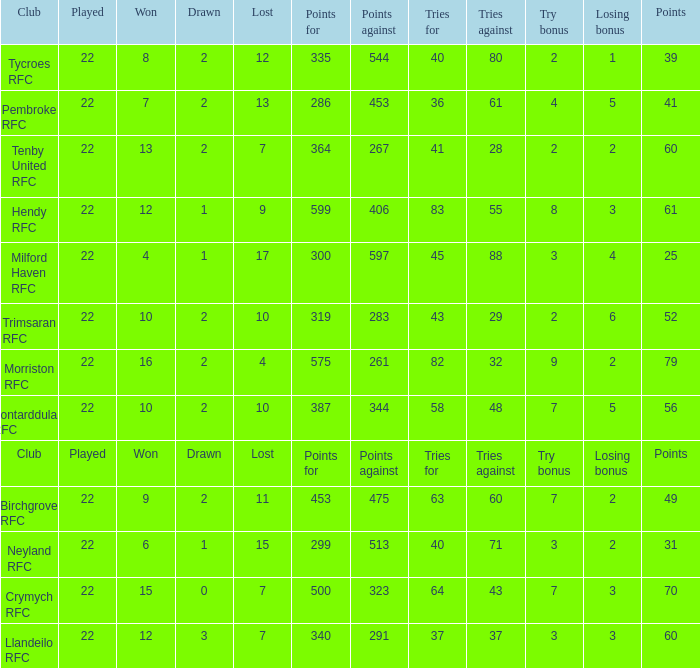Could you parse the entire table as a dict? {'header': ['Club', 'Played', 'Won', 'Drawn', 'Lost', 'Points for', 'Points against', 'Tries for', 'Tries against', 'Try bonus', 'Losing bonus', 'Points'], 'rows': [['Tycroes RFC', '22', '8', '2', '12', '335', '544', '40', '80', '2', '1', '39'], ['Pembroke RFC', '22', '7', '2', '13', '286', '453', '36', '61', '4', '5', '41'], ['Tenby United RFC', '22', '13', '2', '7', '364', '267', '41', '28', '2', '2', '60'], ['Hendy RFC', '22', '12', '1', '9', '599', '406', '83', '55', '8', '3', '61'], ['Milford Haven RFC', '22', '4', '1', '17', '300', '597', '45', '88', '3', '4', '25'], ['Trimsaran RFC', '22', '10', '2', '10', '319', '283', '43', '29', '2', '6', '52'], ['Morriston RFC', '22', '16', '2', '4', '575', '261', '82', '32', '9', '2', '79'], ['Pontarddulais RFC', '22', '10', '2', '10', '387', '344', '58', '48', '7', '5', '56'], ['Club', 'Played', 'Won', 'Drawn', 'Lost', 'Points for', 'Points against', 'Tries for', 'Tries against', 'Try bonus', 'Losing bonus', 'Points'], ['Birchgrove RFC', '22', '9', '2', '11', '453', '475', '63', '60', '7', '2', '49'], ['Neyland RFC', '22', '6', '1', '15', '299', '513', '40', '71', '3', '2', '31'], ['Crymych RFC', '22', '15', '0', '7', '500', '323', '64', '43', '7', '3', '70'], ['Llandeilo RFC', '22', '12', '3', '7', '340', '291', '37', '37', '3', '3', '60']]} What's the won with try bonus being 8 12.0. 